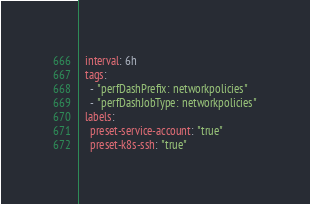<code> <loc_0><loc_0><loc_500><loc_500><_YAML_>  interval: 6h
  tags:
    - "perfDashPrefix: networkpolicies"
    - "perfDashJobType: networkpolicies"
  labels:
    preset-service-account: "true"
    preset-k8s-ssh: "true"</code> 